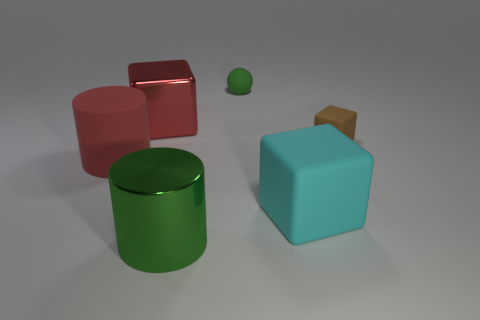Add 4 big gray shiny blocks. How many objects exist? 10 Subtract all spheres. How many objects are left? 5 Add 4 metal cubes. How many metal cubes exist? 5 Subtract 1 red blocks. How many objects are left? 5 Subtract all green spheres. Subtract all green matte objects. How many objects are left? 4 Add 1 large red metal things. How many large red metal things are left? 2 